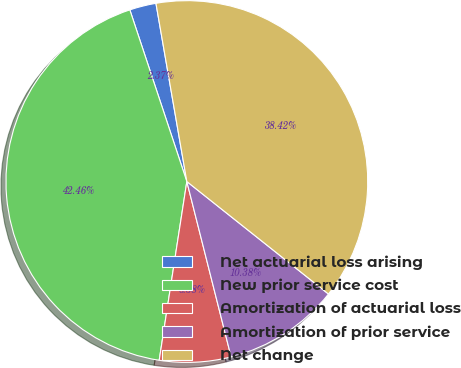<chart> <loc_0><loc_0><loc_500><loc_500><pie_chart><fcel>Net actuarial loss arising<fcel>New prior service cost<fcel>Amortization of actuarial loss<fcel>Amortization of prior service<fcel>Net change<nl><fcel>2.37%<fcel>42.46%<fcel>6.38%<fcel>10.38%<fcel>38.42%<nl></chart> 